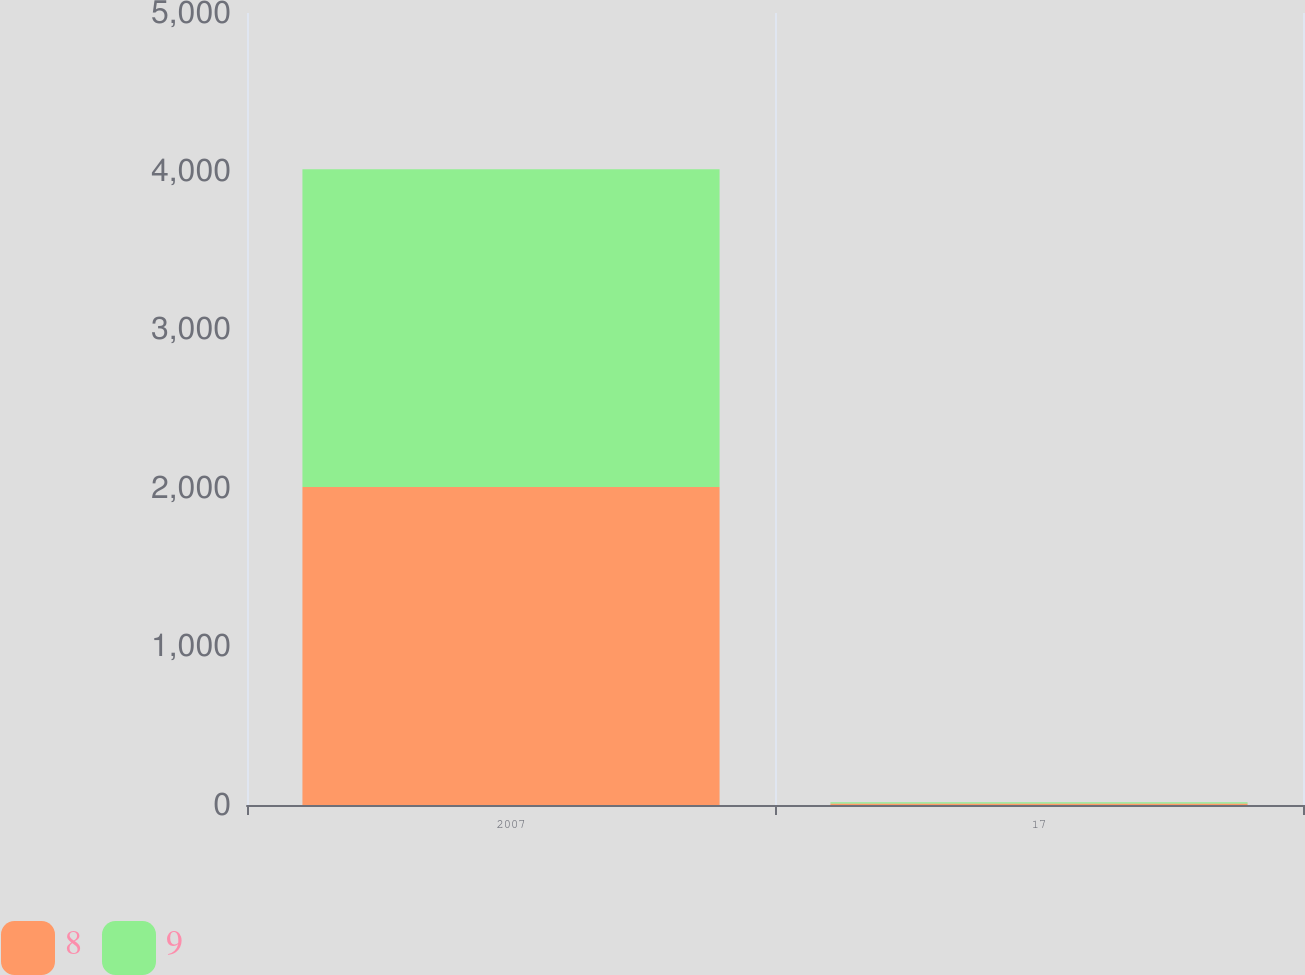Convert chart to OTSL. <chart><loc_0><loc_0><loc_500><loc_500><stacked_bar_chart><ecel><fcel>2007<fcel>17<nl><fcel>8<fcel>2007<fcel>9<nl><fcel>9<fcel>2007<fcel>8<nl></chart> 